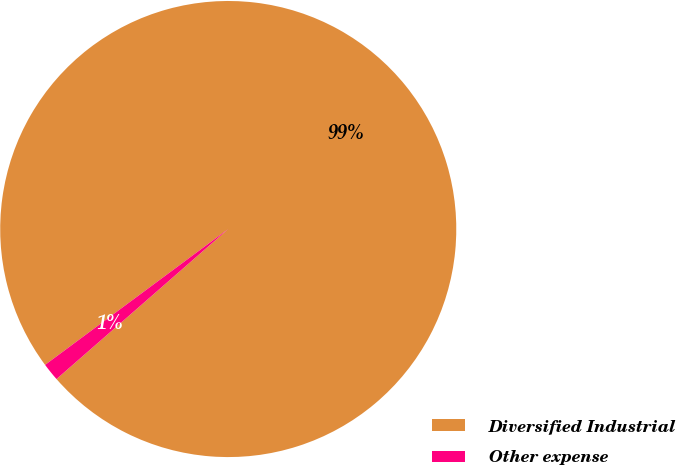Convert chart to OTSL. <chart><loc_0><loc_0><loc_500><loc_500><pie_chart><fcel>Diversified Industrial<fcel>Other expense<nl><fcel>98.73%<fcel>1.27%<nl></chart> 